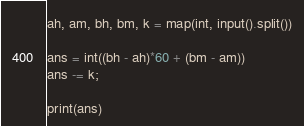<code> <loc_0><loc_0><loc_500><loc_500><_Python_>ah, am, bh, bm, k = map(int, input().split())

ans = int((bh - ah)*60 + (bm - am))
ans -= k;

print(ans)</code> 